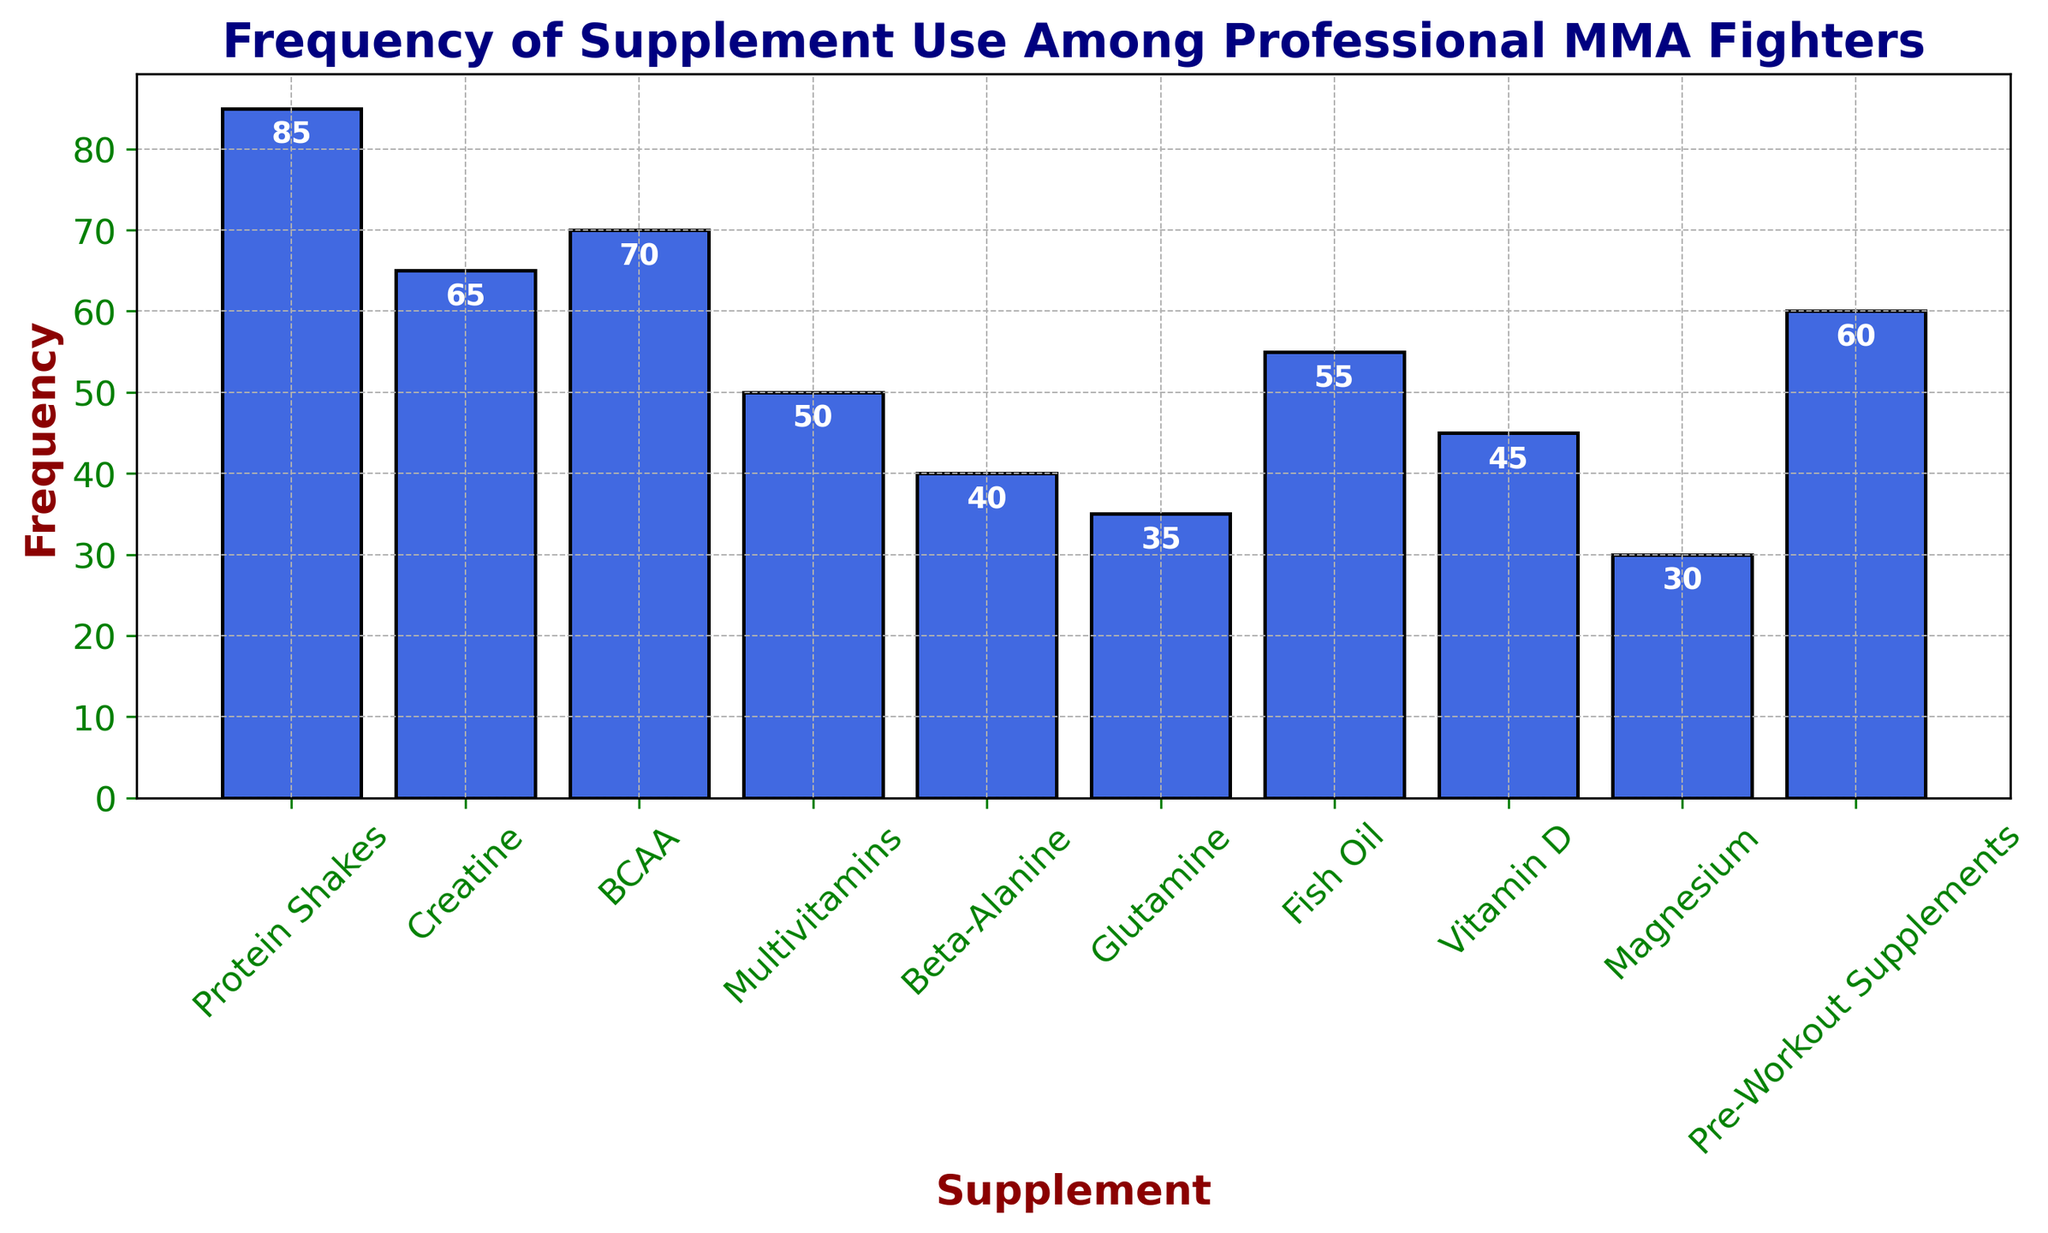Which supplement is used most frequently by professional MMA fighters? The tallest bar represents the supplement with the highest frequency. Protein Shakes have the tallest bar at a frequency of 85.
Answer: Protein Shakes Which two supplements have the closest frequencies? Looking at the heights of the bars, BCAA and Creatine have very close frequencies, with BCAA at 70 and Creatine at 65 (a difference of 5).
Answer: BCAA and Creatine What is the combined frequency of Multivitamins and Fish Oil? The frequencies for Multivitamins and Fish Oil are 50 and 55, respectively. Adding them together: 50 + 55 = 105.
Answer: 105 How many more fighters use Protein Shakes compared to Vitamin D? The frequency for Protein Shakes is 85 and for Vitamin D is 45. Subtracting the two values gives: 85 - 45 = 40.
Answer: 40 Which supplement is used least frequently, and what is its frequency? The shortest bar represents the least frequently used supplement, which is Magnesium with a frequency of 30.
Answer: Magnesium, 30 Rank the supplements from most to least frequently used. By comparing the heights of the bars from tallest to shortest: Protein Shakes (85), BCAA (70), Creatine (65), Pre-Workout Supplements (60), Fish Oil (55), Multivitamins (50), Vitamin D (45), Beta-Alanine (40), Glutamine (35), Magnesium (30).
Answer: Protein Shakes, BCAA, Creatine, Pre-Workout Supplements, Fish Oil, Multivitamins, Vitamin D, Beta-Alanine, Glutamine, Magnesium What is the frequency difference between the highest and lowest used supplements? The highest frequency is for Protein Shakes (85) and the lowest is for Magnesium (30). The difference is 85 - 30 = 55.
Answer: 55 What is the average frequency of use for all supplements shown? Sum all the frequencies: 85+65+70+50+40+35+55+45+30+60 = 535. There are 10 supplements, so the average is 535 / 10 = 53.5.
Answer: 53.5 Which supplement has a frequency closest to the average frequency of all supplements? The average frequency of all supplements is 53.5. Comparing each frequency to this value, Fish Oil has a frequency of 55, which is the closest.
Answer: Fish Oil 